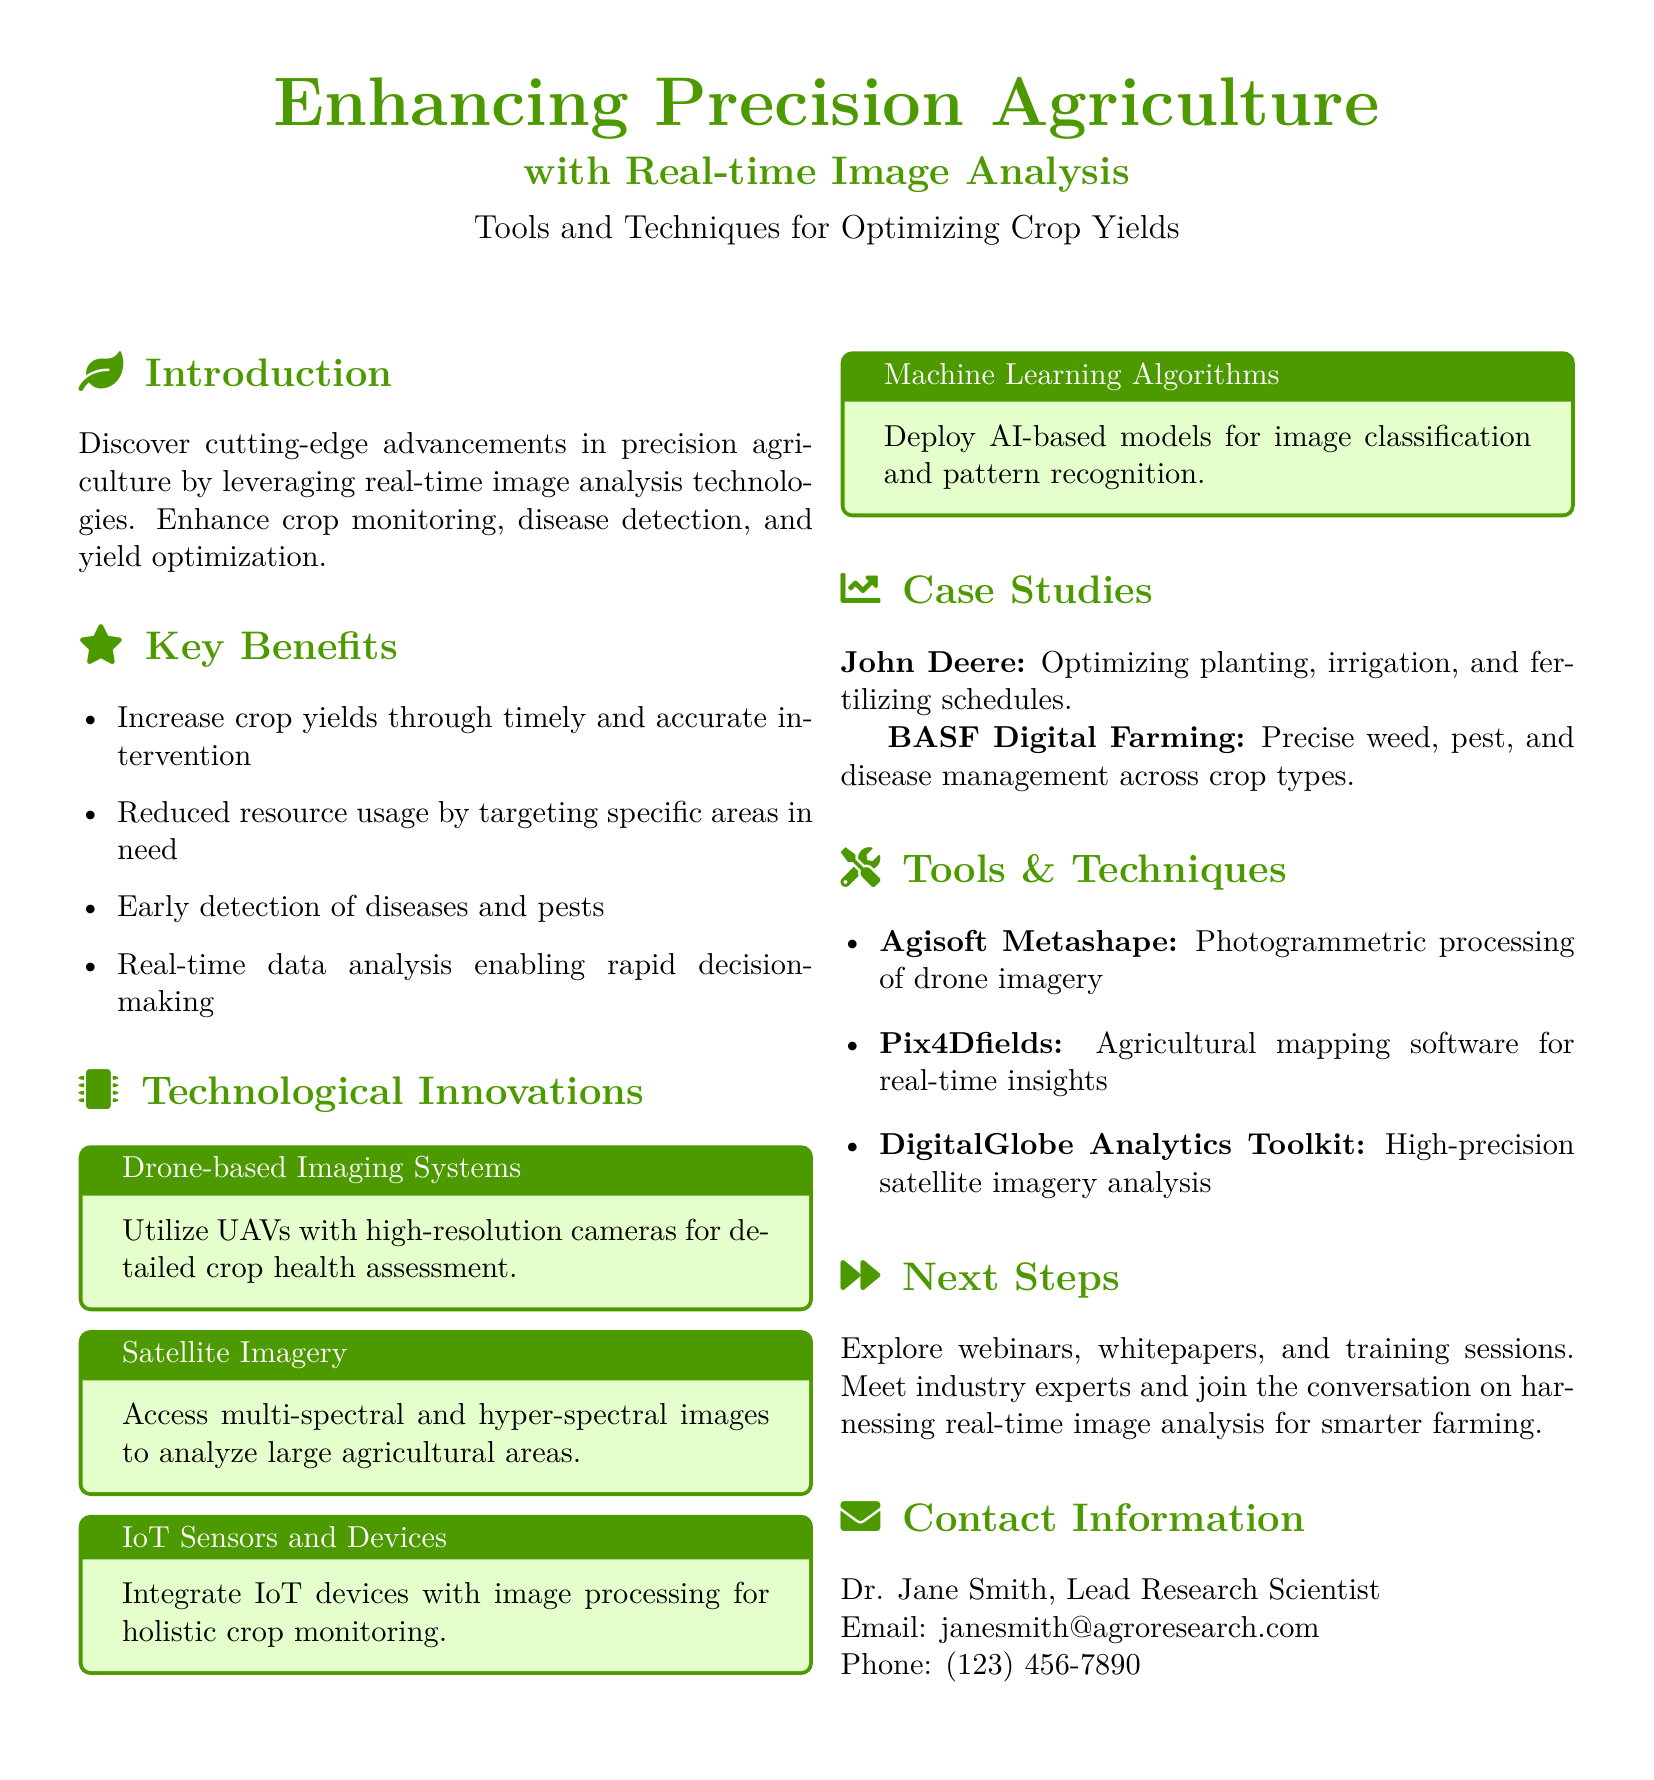What is the main focus of the flyer? The flyer highlights advancements in precision agriculture using real-time image analysis technologies.
Answer: Enhancing Precision Agriculture with Real-time Image Analysis Who is the lead research scientist mentioned in the flyer? The document lists Dr. Jane Smith as the contact person for the flyer.
Answer: Dr. Jane Smith What is one key benefit of utilizing real-time image analysis? The document states multiple benefits, including increased crop yields through timely and accurate intervention.
Answer: Increase crop yields What type of imaging systems does the flyer mention as a technological innovation? The flyer specifically references drone-based imaging systems for crop health assessment.
Answer: Drone-based Imaging Systems Which software is mentioned for photogrammetric processing? Agisoft Metashape is identified as the software for photogrammetric processing of drone imagery.
Answer: Agisoft Metashape What is the purpose of the case studies section in the flyer? The case studies exemplify real-world applications of precision agriculture technologies by companies mentioned.
Answer: Precision weed, pest, and disease management What type of devices are integrated with image processing according to the flyer? The flyer discusses the integration of IoT devices with image processing for crop monitoring.
Answer: IoT Sensors and Devices What is suggested as a next step for the audience? The flyer encourages exploring webinars, whitepapers, and training sessions for further learning.
Answer: Explore webinars, whitepapers, and training sessions 